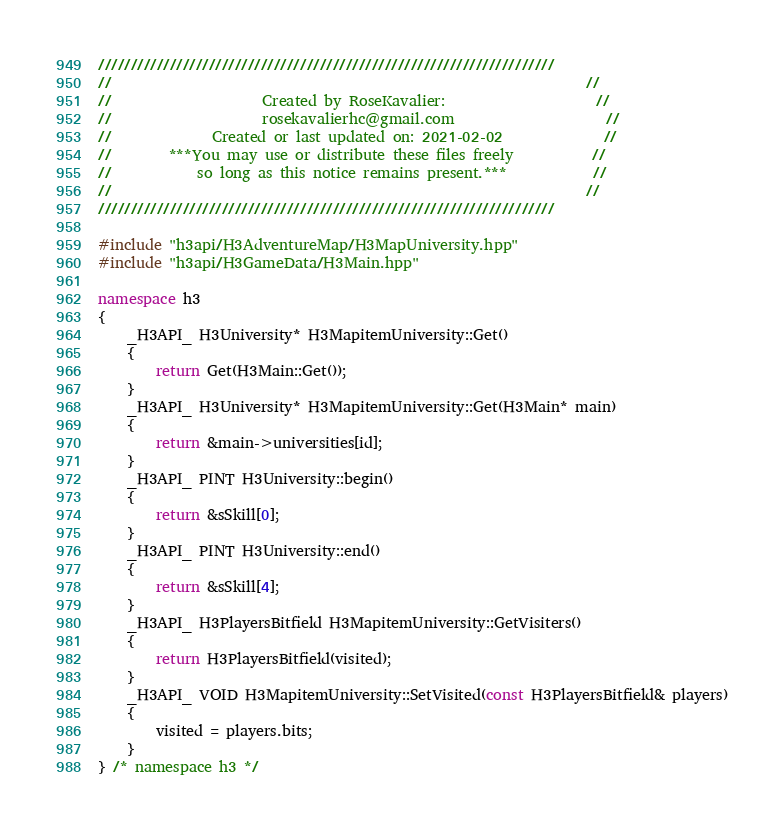Convert code to text. <code><loc_0><loc_0><loc_500><loc_500><_C++_>//////////////////////////////////////////////////////////////////////
//                                                                  //
//                     Created by RoseKavalier:                     //
//                     rosekavalierhc@gmail.com                     //
//              Created or last updated on: 2021-02-02              //
//        ***You may use or distribute these files freely           //
//            so long as this notice remains present.***            //
//                                                                  //
//////////////////////////////////////////////////////////////////////

#include "h3api/H3AdventureMap/H3MapUniversity.hpp"
#include "h3api/H3GameData/H3Main.hpp"

namespace h3
{
	_H3API_ H3University* H3MapitemUniversity::Get()
	{
		return Get(H3Main::Get());
	}
	_H3API_ H3University* H3MapitemUniversity::Get(H3Main* main)
	{
		return &main->universities[id];
	}
	_H3API_ PINT H3University::begin()
	{
		return &sSkill[0];
	}
	_H3API_ PINT H3University::end()
	{
		return &sSkill[4];
	}
	_H3API_ H3PlayersBitfield H3MapitemUniversity::GetVisiters()
	{
		return H3PlayersBitfield(visited);
	}
	_H3API_ VOID H3MapitemUniversity::SetVisited(const H3PlayersBitfield& players)
	{
		visited = players.bits;
	}
} /* namespace h3 */
</code> 